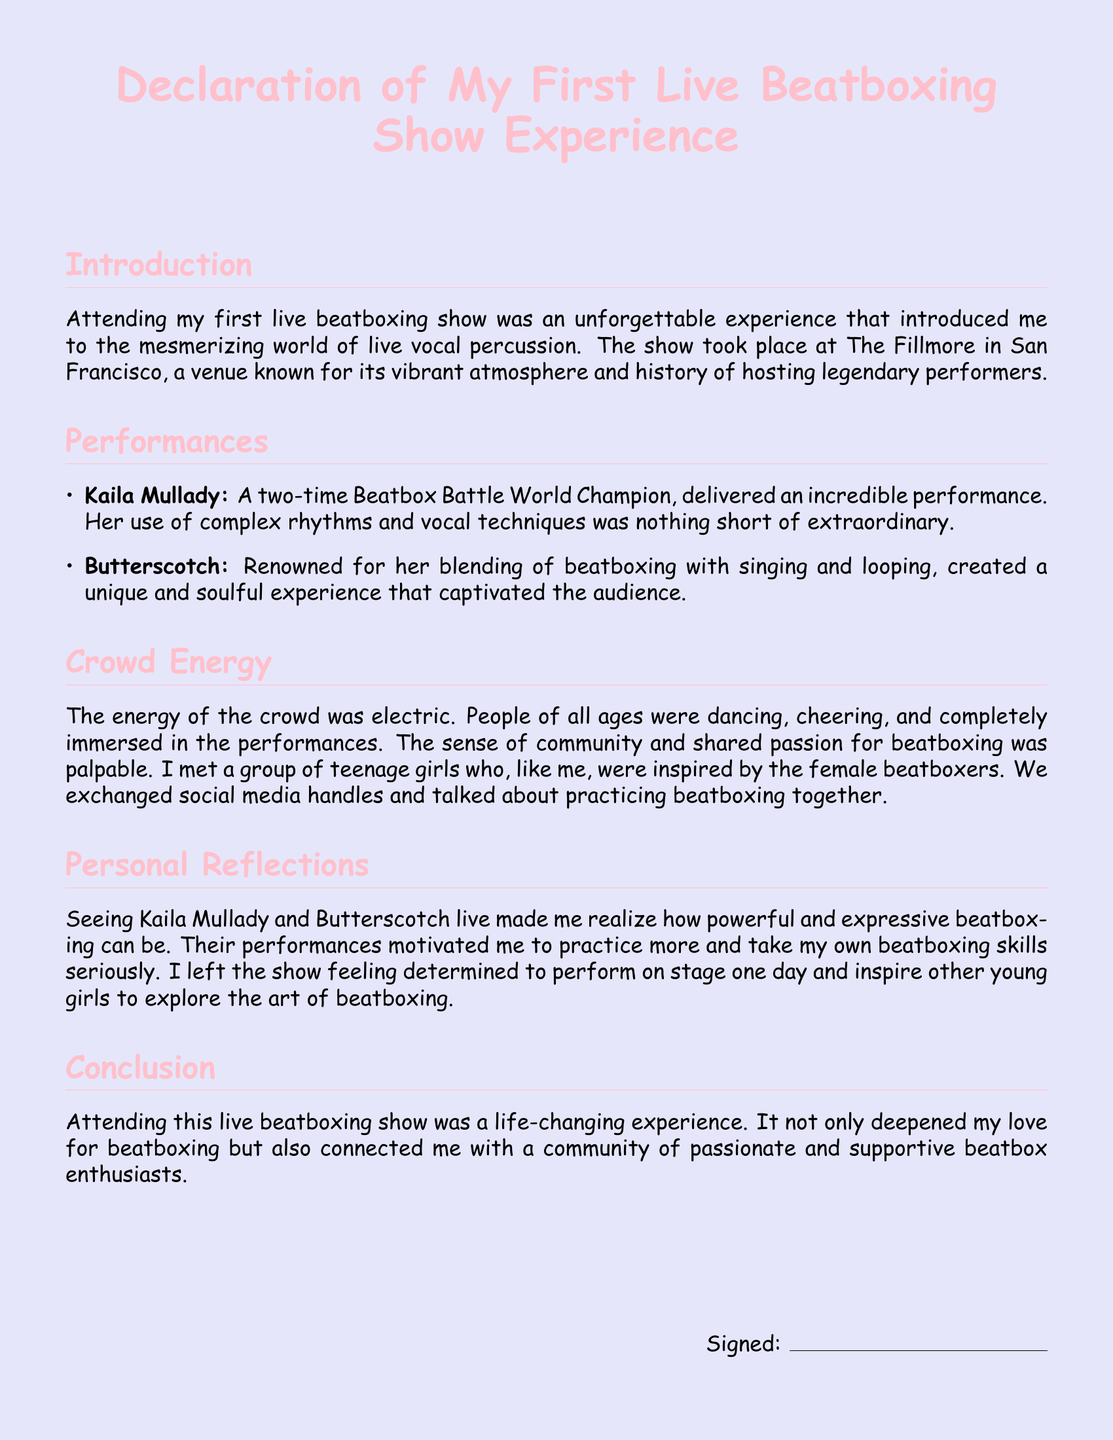what is the name of the venue? The name of the venue where the beatboxing show took place is mentioned in the introduction.
Answer: The Fillmore who performed at the show? The document lists two female beatboxers who performed at the show.
Answer: Kaila Mullady and Butterscotch how many times has Kaila Mullady won the Beatbox Battle World Championship? The document states the title of Kaila Mullady in the performances section.
Answer: Two times what was the atmosphere like during the show? The document describes the crowd's vibe in the crowd energy section.
Answer: Electric what motivated the author after seeing the performances? The personal reflections section provides insight into the author's feelings after the show.
Answer: Practice more and take beatboxing seriously how did the author connect with other attendees? The crowd energy section explains how the author interacted with others.
Answer: Exchanged social media handles what type of experience did Butterscotch create with her performance? The performances section describes Butterscotch's performance style.
Answer: Unique and soulful what was the author's overall impression of the show? The conclusion summarizes the author's feelings towards the event.
Answer: Life-changing 